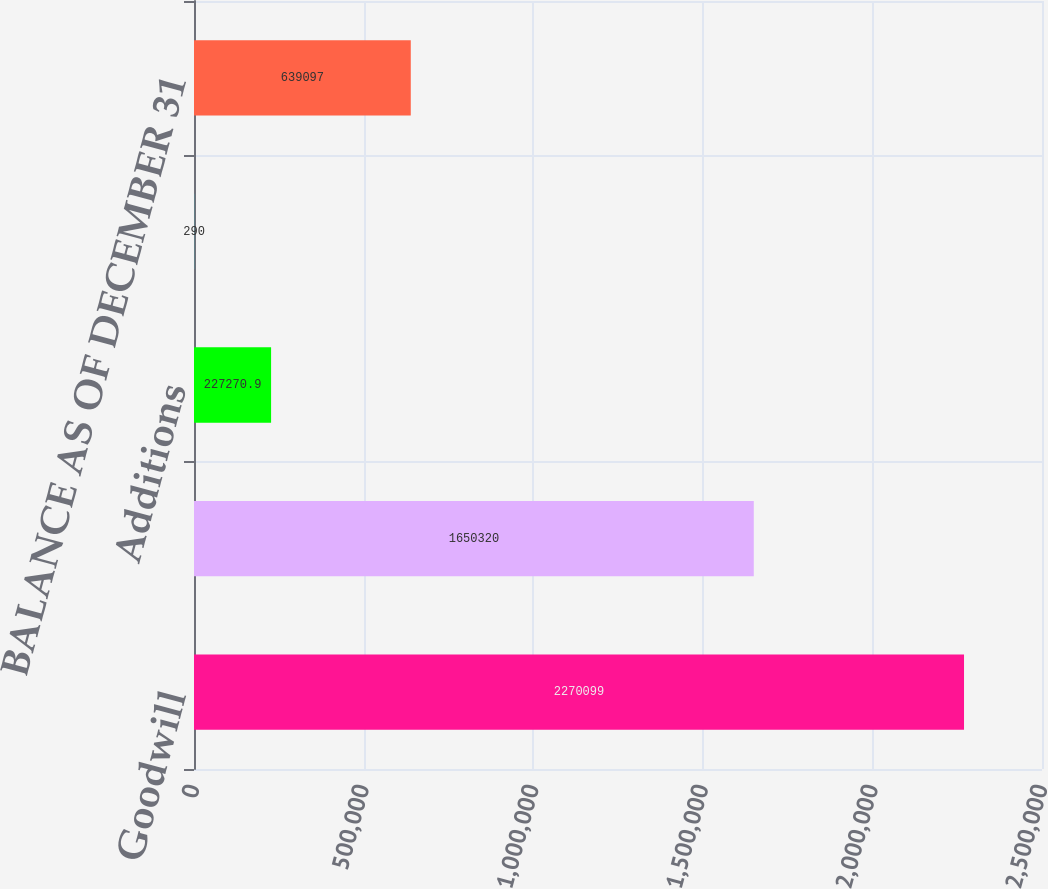<chart> <loc_0><loc_0><loc_500><loc_500><bar_chart><fcel>Goodwill<fcel>Accumulated impairment losses<fcel>Additions<fcel>Foreign currency translation<fcel>BALANCE AS OF DECEMBER 31<nl><fcel>2.2701e+06<fcel>1.65032e+06<fcel>227271<fcel>290<fcel>639097<nl></chart> 